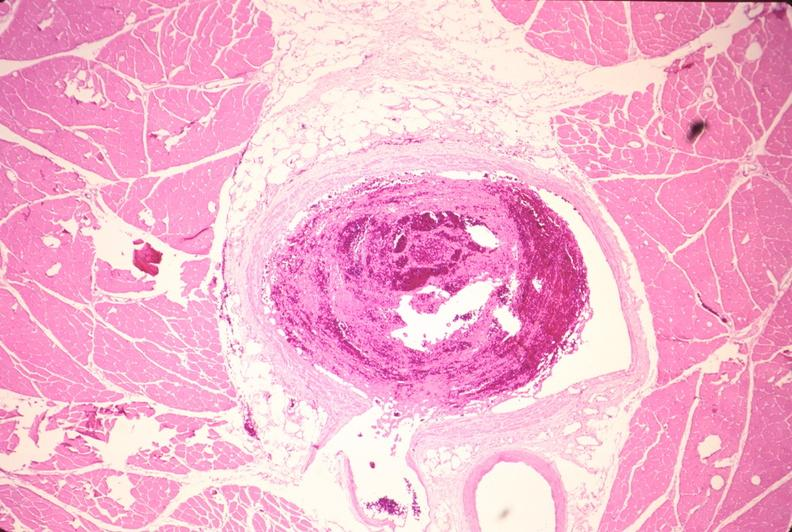does capillary show leg veins, thrombus?
Answer the question using a single word or phrase. No 